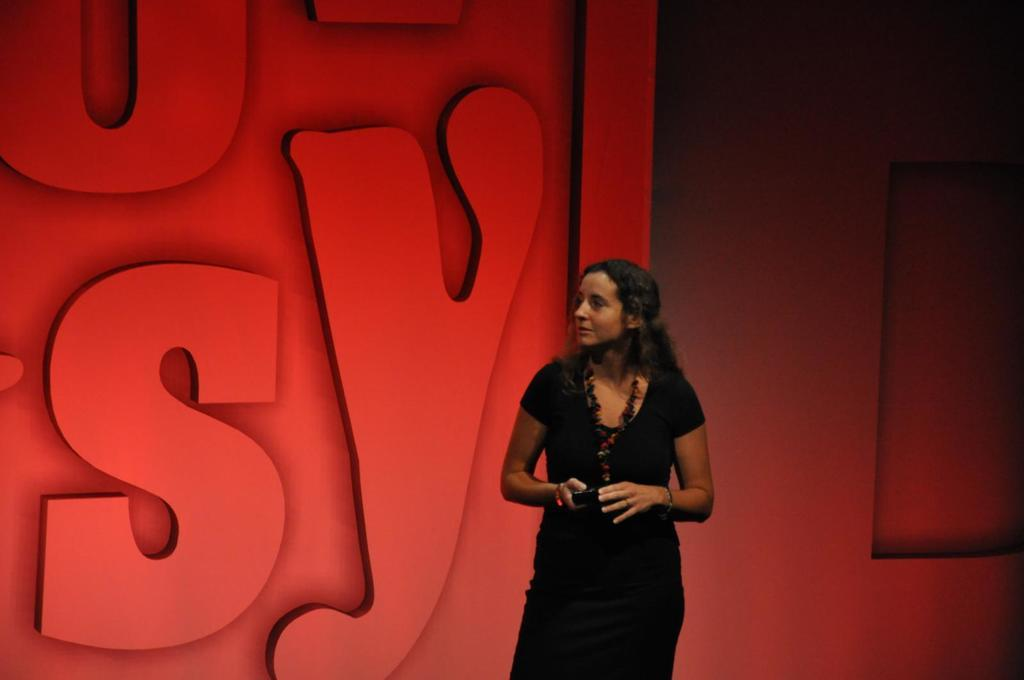What is the main subject of the image? The main subject of the image is a woman. What is the woman doing in the image? The woman is standing in the image. What is the woman holding in her hands? The woman is holding an object in her hands. What can be seen in the background of the image? There are texts written on a platform in the background of the image. What type of rabbit can be seen playing on the platform in the image? There is no rabbit present in the image, and no playing is depicted. 